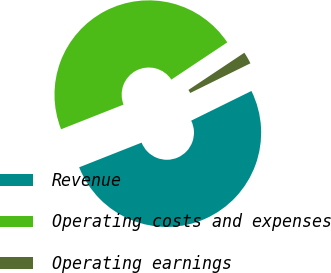Convert chart. <chart><loc_0><loc_0><loc_500><loc_500><pie_chart><fcel>Revenue<fcel>Operating costs and expenses<fcel>Operating earnings<nl><fcel>51.3%<fcel>46.64%<fcel>2.06%<nl></chart> 